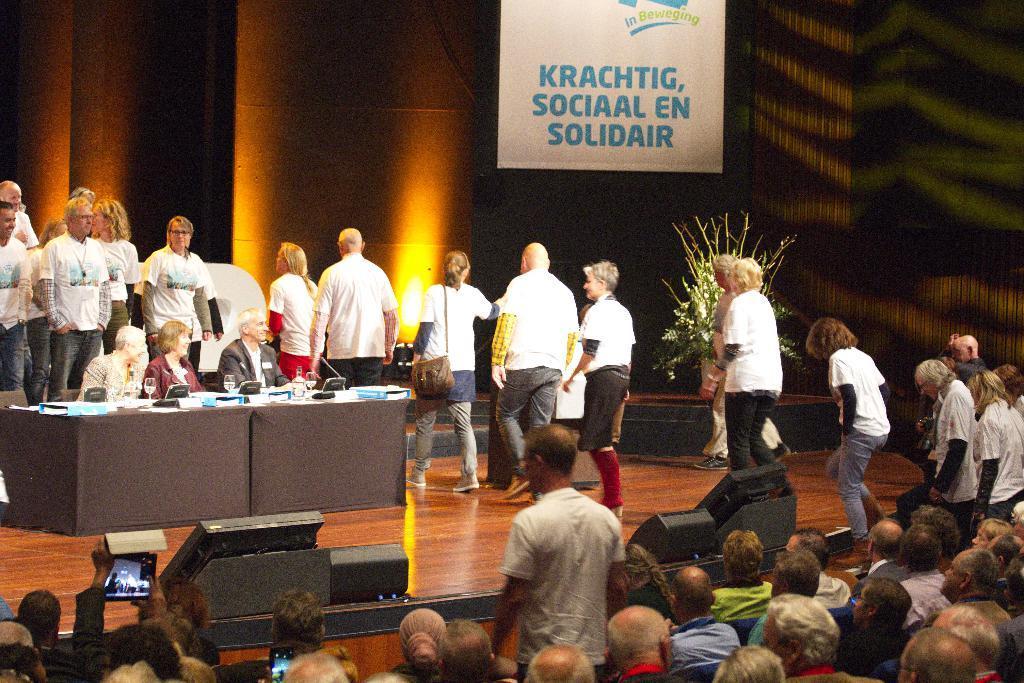How would you summarize this image in a sentence or two? In this image, there is a brown color floor, there are some people sitting on the chairs, at the right side there are some people walking, at the left side there are some tables and there are some people sitting on the chairs, at the top there is a white color poster. 